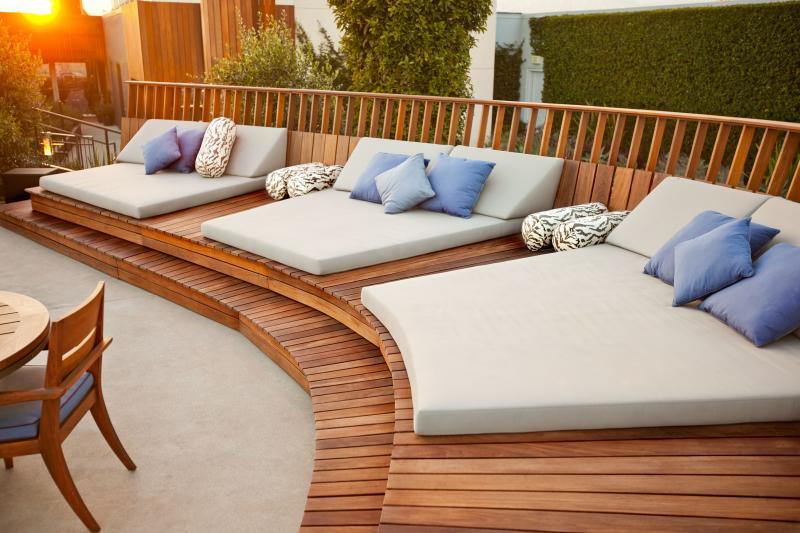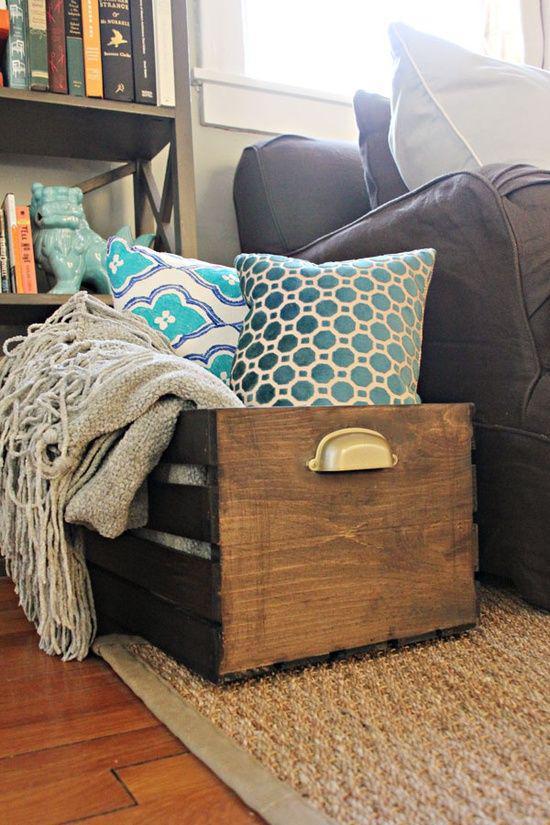The first image is the image on the left, the second image is the image on the right. Examine the images to the left and right. Is the description "Three throw cushions sit on the sofa in the image on the right." accurate? Answer yes or no. No. The first image is the image on the left, the second image is the image on the right. For the images displayed, is the sentence "The right image features multiple fringed pillows with a textured look and colors that include burgundy and brown." factually correct? Answer yes or no. No. 